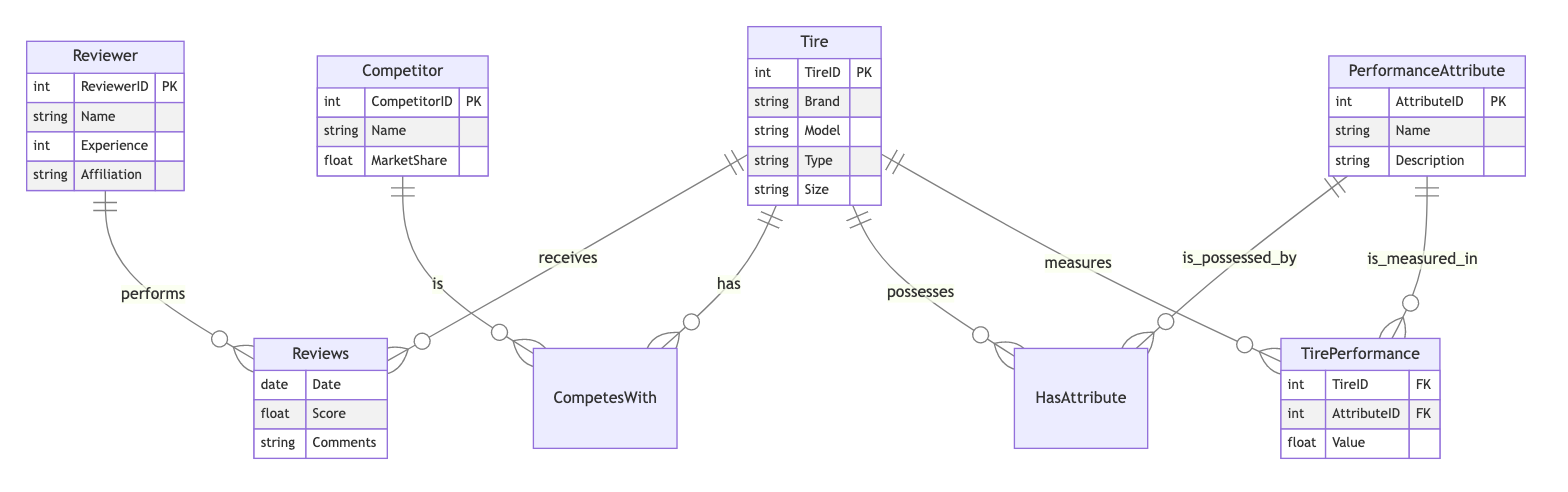What is the primary key of the Reviewer entity? The Reviewer entity has a primary key attribute labeled ReviewerID, which uniquely identifies each reviewer in the system.
Answer: ReviewerID How many relationships exist in the diagram? The diagram contains three distinct relationships: Reviews, CompetesWith, and HasAttribute. Each one links different entities, which can be counted for a total.
Answer: 3 Which attribute describes the market position of a Competitor? The Competitor entity includes an attribute called MarketShare, which quantifies the competitor's market presence relative to others.
Answer: MarketShare What type of relationship exists between Tire and PerformanceAttribute? The relationship between Tire and PerformanceAttribute is labeled as HasAttribute, indicating a possession dynamic where tires can possess multiple performance attributes.
Answer: HasAttribute What entity measures the performance values of Tires? The TirePerformance entity is designated to measure the performance values of various tires based on different attributes, reflecting their performance ratings.
Answer: TirePerformance How many attributes does the PerformanceAttribute entity have? The PerformanceAttribute entity contains three attributes: AttributeID, Name, and Description, which define its structure and information included.
Answer: 3 What is the foreign key in the TirePerformance entity? The TirePerformance entity contains foreign keys TireID and AttributeID, which link the performance measurements back to their respective Tire and PerformanceAttribute records.
Answer: TireID, AttributeID Which entity is described by the relationship CompetesWith? The relationship CompetesWith describes the competition between the Tire entity and the Competitor entity, indicating that certain tires compete against specific competitors in the market.
Answer: Tire, Competitor What does the Reviews relationship connect? The Reviews relationship connects the Reviewer entity with the Tire entity, allowing for the assessment and commentary of tire performance by reviewers.
Answer: Reviewer, Tire 